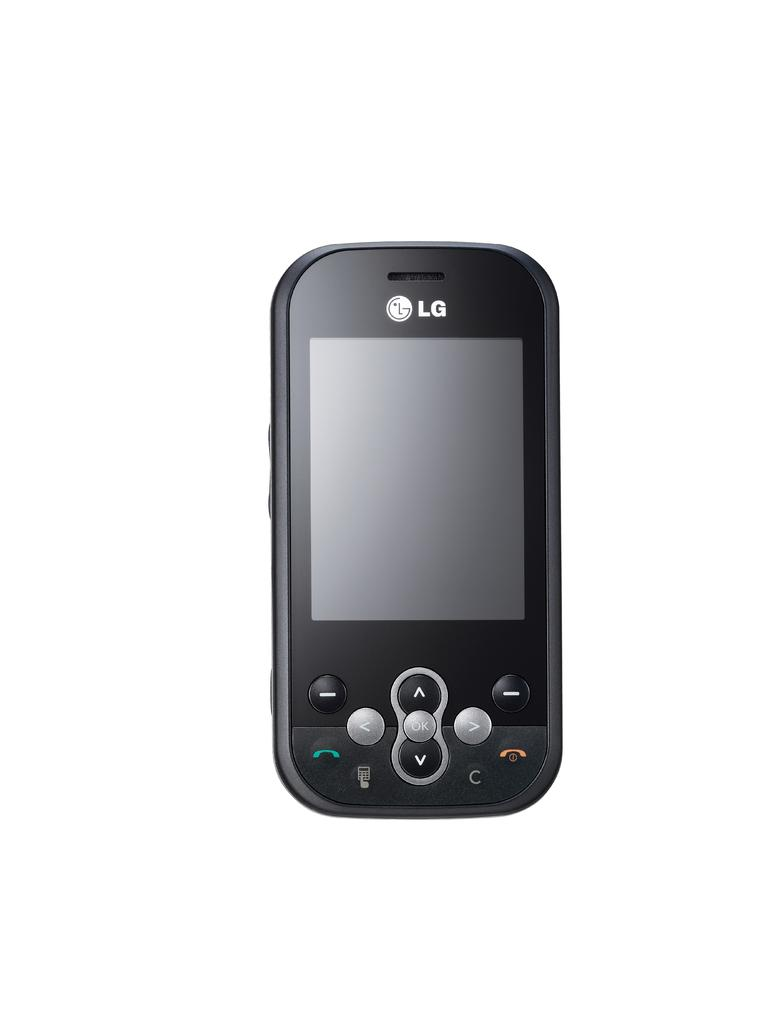<image>
Relay a brief, clear account of the picture shown. A small black LG phone against a white black drop. 